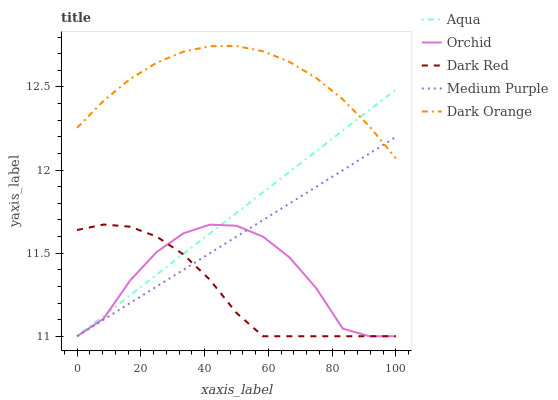Does Aqua have the minimum area under the curve?
Answer yes or no. No. Does Aqua have the maximum area under the curve?
Answer yes or no. No. Is Dark Red the smoothest?
Answer yes or no. No. Is Dark Red the roughest?
Answer yes or no. No. Does Dark Orange have the lowest value?
Answer yes or no. No. Does Dark Red have the highest value?
Answer yes or no. No. Is Orchid less than Dark Orange?
Answer yes or no. Yes. Is Dark Orange greater than Orchid?
Answer yes or no. Yes. Does Orchid intersect Dark Orange?
Answer yes or no. No. 